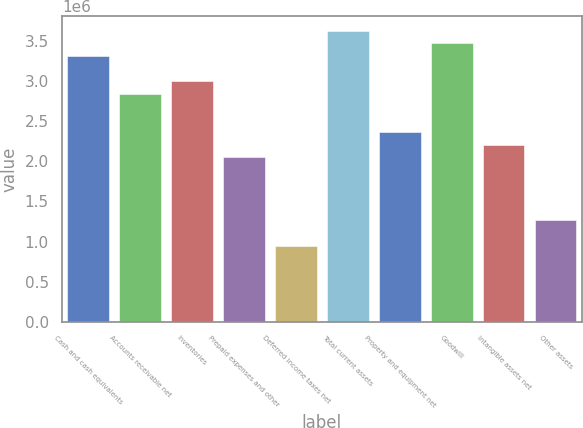Convert chart. <chart><loc_0><loc_0><loc_500><loc_500><bar_chart><fcel>Cash and cash equivalents<fcel>Accounts receivable net<fcel>Inventories<fcel>Prepaid expenses and other<fcel>Deferred income taxes net<fcel>Total current assets<fcel>Property and equipment net<fcel>Goodwill<fcel>Intangible assets net<fcel>Other assets<nl><fcel>3.31358e+06<fcel>2.84052e+06<fcel>2.99821e+06<fcel>2.05209e+06<fcel>948282<fcel>3.62896e+06<fcel>2.36746e+06<fcel>3.47127e+06<fcel>2.20978e+06<fcel>1.26366e+06<nl></chart> 